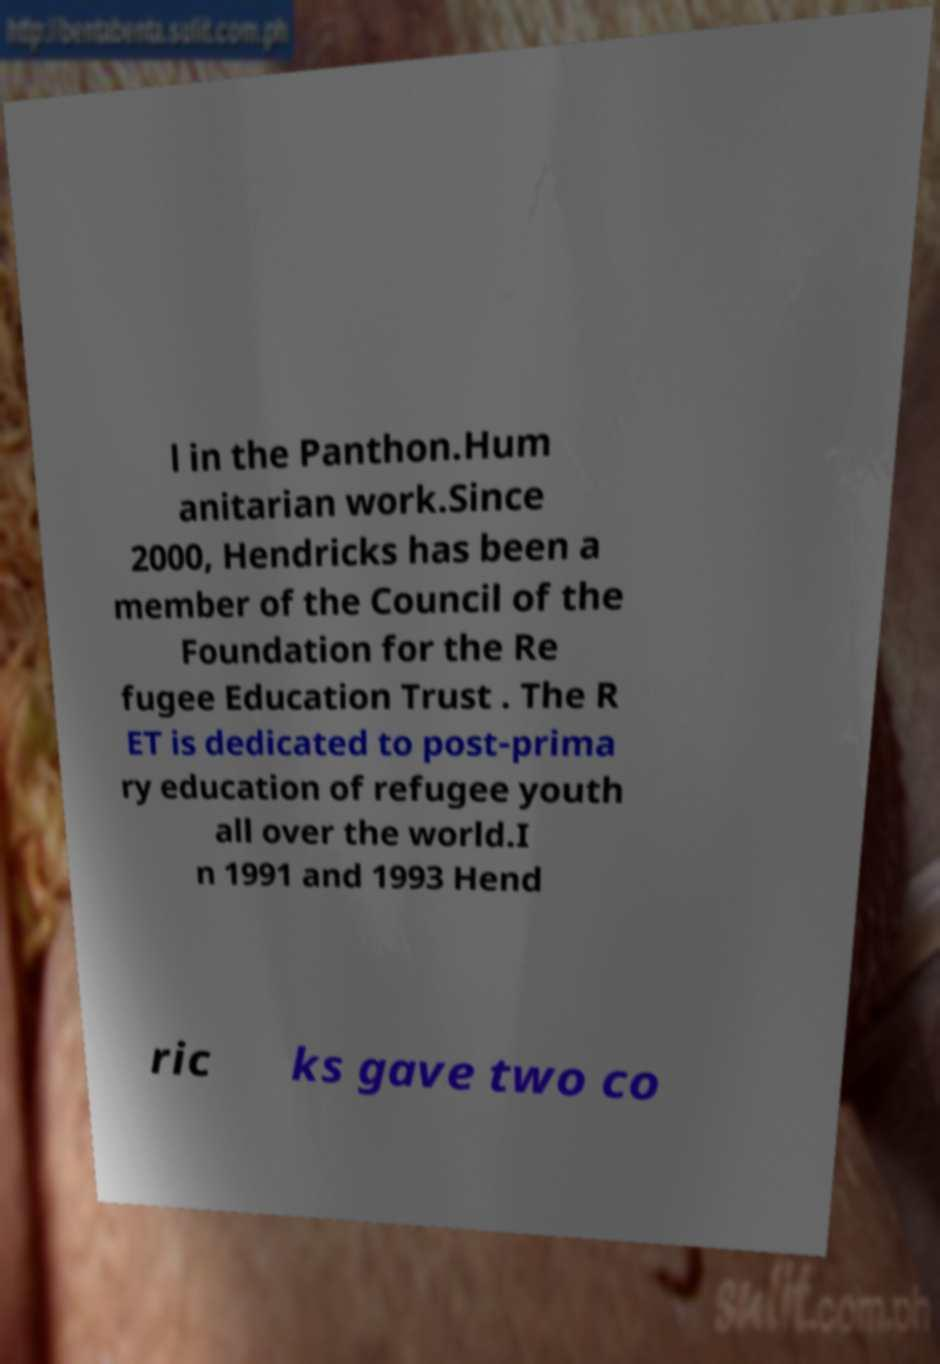Can you read and provide the text displayed in the image?This photo seems to have some interesting text. Can you extract and type it out for me? l in the Panthon.Hum anitarian work.Since 2000, Hendricks has been a member of the Council of the Foundation for the Re fugee Education Trust . The R ET is dedicated to post-prima ry education of refugee youth all over the world.I n 1991 and 1993 Hend ric ks gave two co 